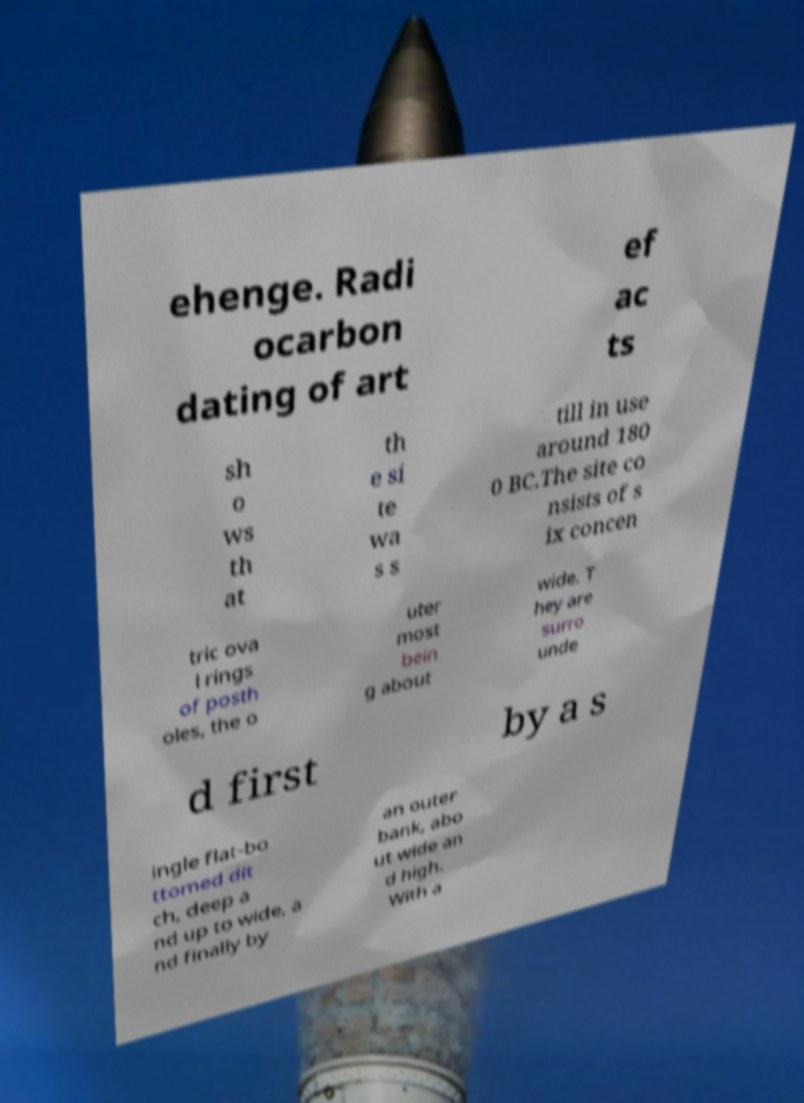Can you accurately transcribe the text from the provided image for me? ehenge. Radi ocarbon dating of art ef ac ts sh o ws th at th e si te wa s s till in use around 180 0 BC.The site co nsists of s ix concen tric ova l rings of posth oles, the o uter most bein g about wide. T hey are surro unde d first by a s ingle flat-bo ttomed dit ch, deep a nd up to wide, a nd finally by an outer bank, abo ut wide an d high. With a 